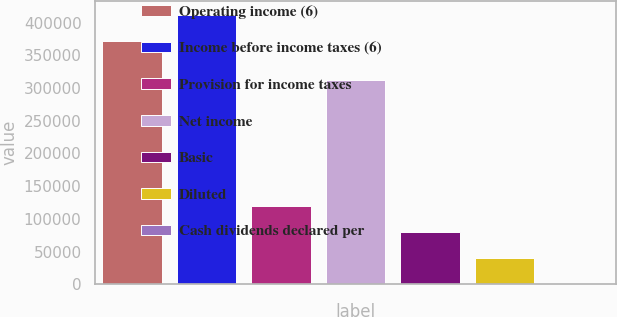Convert chart. <chart><loc_0><loc_0><loc_500><loc_500><bar_chart><fcel>Operating income (6)<fcel>Income before income taxes (6)<fcel>Provision for income taxes<fcel>Net income<fcel>Basic<fcel>Diluted<fcel>Cash dividends declared per<nl><fcel>372040<fcel>412094<fcel>120163<fcel>312723<fcel>80109<fcel>40054.6<fcel>0.2<nl></chart> 